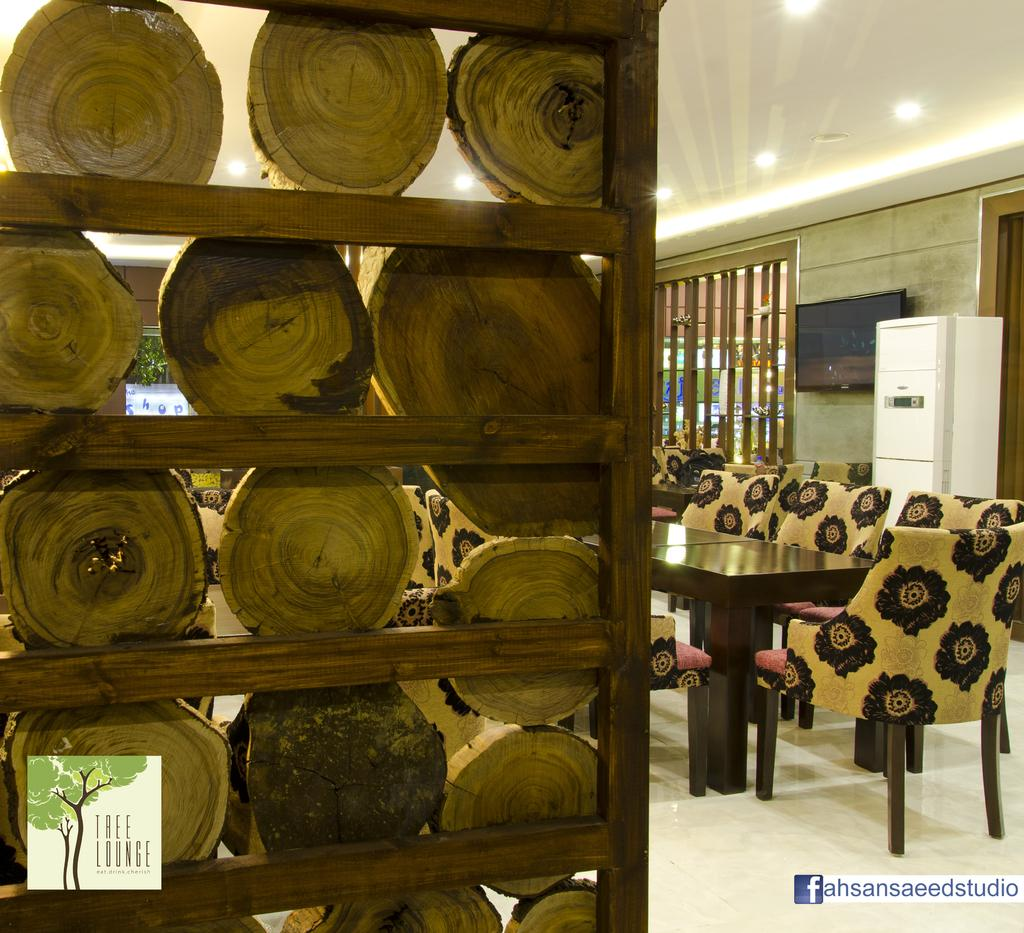What type of furniture is present in the image? There is a table and chairs around the table in the image. What is on the wall in the image? There is a television on the wall. What type of cooking equipment is visible in the image? There are wooden grills in the image. What type of lighting is present in the image? There are electric lights on the roof. What type of vegetation is present in the image? There are plants in the image. What type of storage is present in the image? There are wooden logs placed in a rack. What type of apple is being used to attempt to break the wooden grills in the image? There is no apple or attempt to break the wooden grills present in the image. 